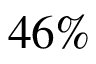Convert formula to latex. <formula><loc_0><loc_0><loc_500><loc_500>4 6 \%</formula> 